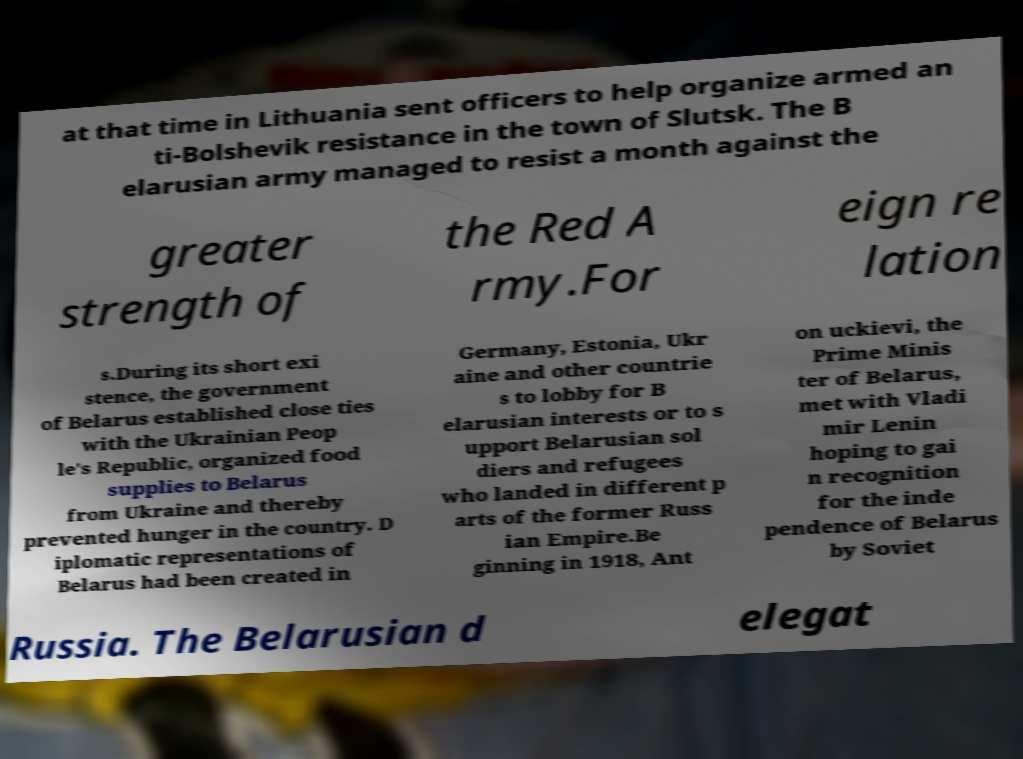What messages or text are displayed in this image? I need them in a readable, typed format. at that time in Lithuania sent officers to help organize armed an ti-Bolshevik resistance in the town of Slutsk. The B elarusian army managed to resist a month against the greater strength of the Red A rmy.For eign re lation s.During its short exi stence, the government of Belarus established close ties with the Ukrainian Peop le's Republic, organized food supplies to Belarus from Ukraine and thereby prevented hunger in the country. D iplomatic representations of Belarus had been created in Germany, Estonia, Ukr aine and other countrie s to lobby for B elarusian interests or to s upport Belarusian sol diers and refugees who landed in different p arts of the former Russ ian Empire.Be ginning in 1918, Ant on uckievi, the Prime Minis ter of Belarus, met with Vladi mir Lenin hoping to gai n recognition for the inde pendence of Belarus by Soviet Russia. The Belarusian d elegat 